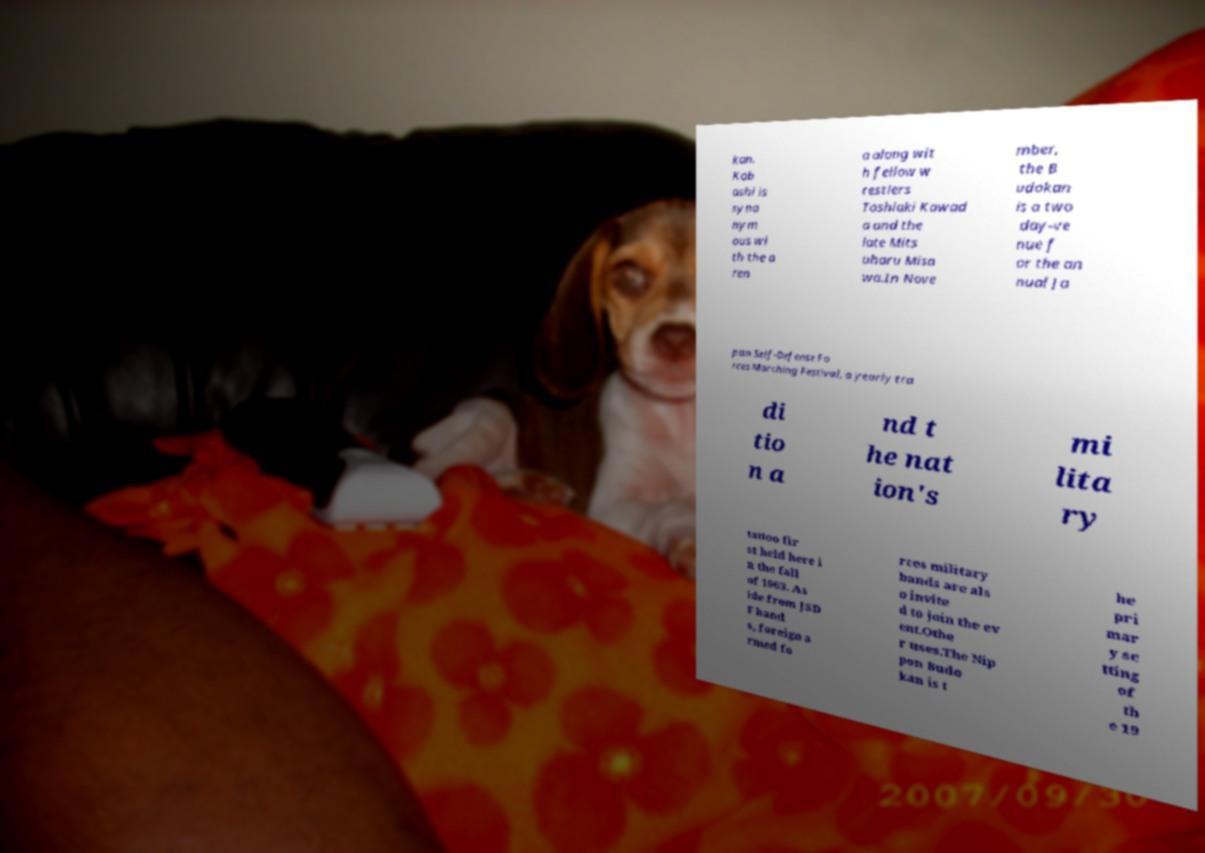I need the written content from this picture converted into text. Can you do that? kan. Kob ashi is syno nym ous wi th the a ren a along wit h fellow w restlers Toshiaki Kawad a and the late Mits uharu Misa wa.In Nove mber, the B udokan is a two day-ve nue f or the an nual Ja pan Self-Defense Fo rces Marching Festival, a yearly tra di tio n a nd t he nat ion's mi lita ry tattoo fir st held here i n the fall of 1963. As ide from JSD F band s, foreign a rmed fo rces military bands are als o invite d to join the ev ent.Othe r uses.The Nip pon Budo kan is t he pri mar y se tting of th e 19 